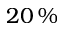<formula> <loc_0><loc_0><loc_500><loc_500>2 0 \, \%</formula> 